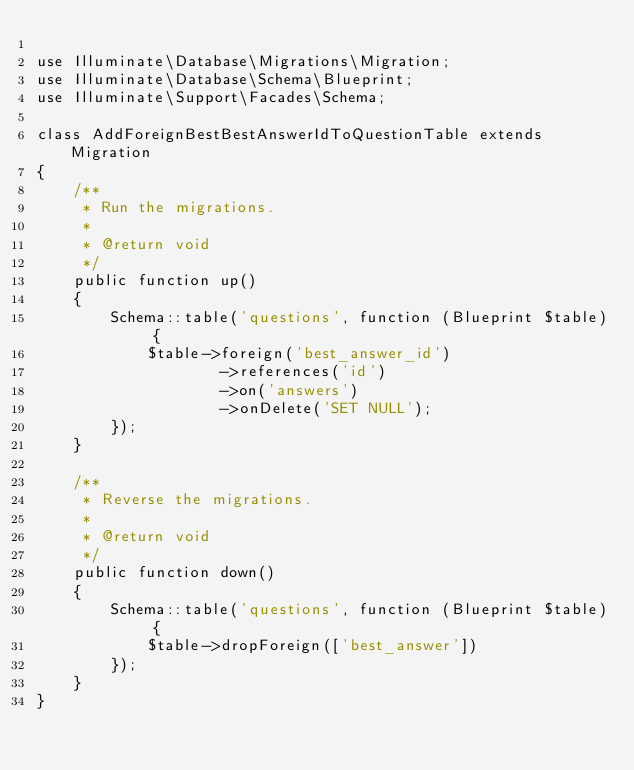<code> <loc_0><loc_0><loc_500><loc_500><_PHP_>
use Illuminate\Database\Migrations\Migration;
use Illuminate\Database\Schema\Blueprint;
use Illuminate\Support\Facades\Schema;

class AddForeignBestBestAnswerIdToQuestionTable extends Migration
{
    /**
     * Run the migrations.
     *
     * @return void
     */
    public function up()
    {
        Schema::table('questions', function (Blueprint $table) {
            $table->foreign('best_answer_id')
                    ->references('id')
                    ->on('answers')
                    ->onDelete('SET NULL');
        });
    }

    /**
     * Reverse the migrations.
     *
     * @return void
     */
    public function down()
    {
        Schema::table('questions', function (Blueprint $table) {
            $table->dropForeign(['best_answer'])
        });
    }
}
</code> 